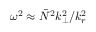Convert formula to latex. <formula><loc_0><loc_0><loc_500><loc_500>\omega ^ { 2 } \approx \bar { N } ^ { 2 } k _ { \perp } ^ { 2 } / k _ { r } ^ { 2 }</formula> 